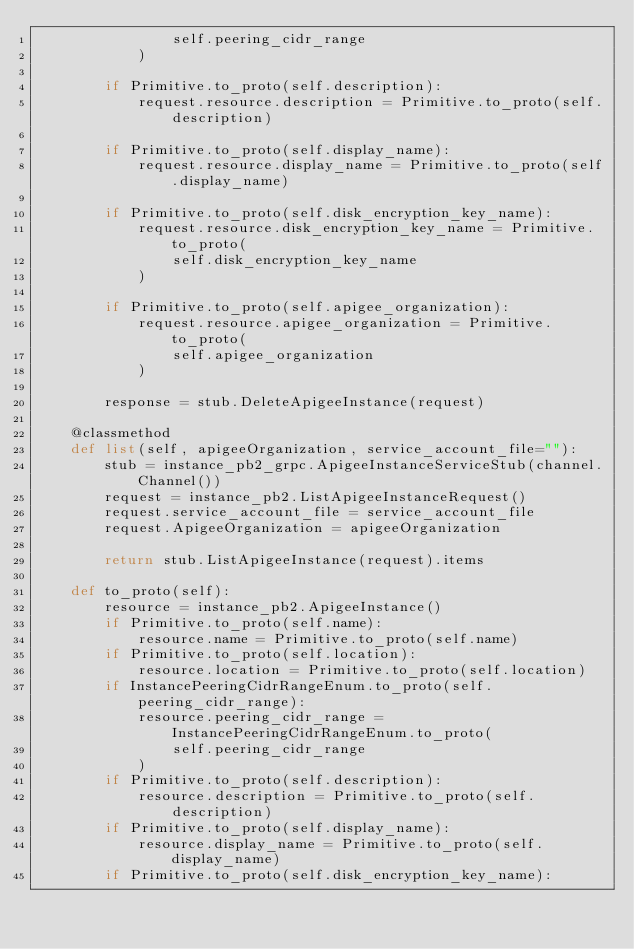<code> <loc_0><loc_0><loc_500><loc_500><_Python_>                self.peering_cidr_range
            )

        if Primitive.to_proto(self.description):
            request.resource.description = Primitive.to_proto(self.description)

        if Primitive.to_proto(self.display_name):
            request.resource.display_name = Primitive.to_proto(self.display_name)

        if Primitive.to_proto(self.disk_encryption_key_name):
            request.resource.disk_encryption_key_name = Primitive.to_proto(
                self.disk_encryption_key_name
            )

        if Primitive.to_proto(self.apigee_organization):
            request.resource.apigee_organization = Primitive.to_proto(
                self.apigee_organization
            )

        response = stub.DeleteApigeeInstance(request)

    @classmethod
    def list(self, apigeeOrganization, service_account_file=""):
        stub = instance_pb2_grpc.ApigeeInstanceServiceStub(channel.Channel())
        request = instance_pb2.ListApigeeInstanceRequest()
        request.service_account_file = service_account_file
        request.ApigeeOrganization = apigeeOrganization

        return stub.ListApigeeInstance(request).items

    def to_proto(self):
        resource = instance_pb2.ApigeeInstance()
        if Primitive.to_proto(self.name):
            resource.name = Primitive.to_proto(self.name)
        if Primitive.to_proto(self.location):
            resource.location = Primitive.to_proto(self.location)
        if InstancePeeringCidrRangeEnum.to_proto(self.peering_cidr_range):
            resource.peering_cidr_range = InstancePeeringCidrRangeEnum.to_proto(
                self.peering_cidr_range
            )
        if Primitive.to_proto(self.description):
            resource.description = Primitive.to_proto(self.description)
        if Primitive.to_proto(self.display_name):
            resource.display_name = Primitive.to_proto(self.display_name)
        if Primitive.to_proto(self.disk_encryption_key_name):</code> 